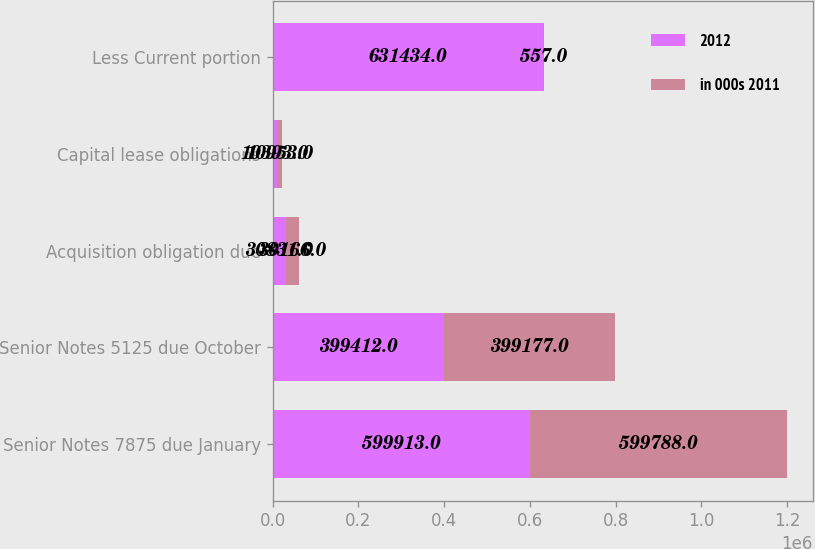Convert chart. <chart><loc_0><loc_0><loc_500><loc_500><stacked_bar_chart><ecel><fcel>Senior Notes 7875 due January<fcel>Senior Notes 5125 due October<fcel>Acquisition obligation due<fcel>Capital lease obligations<fcel>Less Current portion<nl><fcel>2012<fcel>599913<fcel>399412<fcel>30831<fcel>10393<fcel>631434<nl><fcel>in 000s 2011<fcel>599788<fcel>399177<fcel>30166<fcel>10953<fcel>557<nl></chart> 